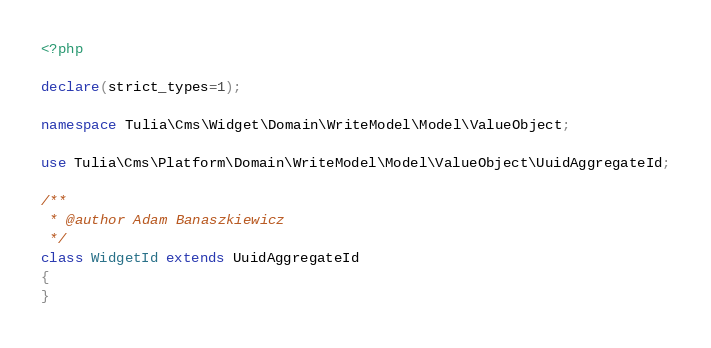<code> <loc_0><loc_0><loc_500><loc_500><_PHP_><?php

declare(strict_types=1);

namespace Tulia\Cms\Widget\Domain\WriteModel\Model\ValueObject;

use Tulia\Cms\Platform\Domain\WriteModel\Model\ValueObject\UuidAggregateId;

/**
 * @author Adam Banaszkiewicz
 */
class WidgetId extends UuidAggregateId
{
}
</code> 